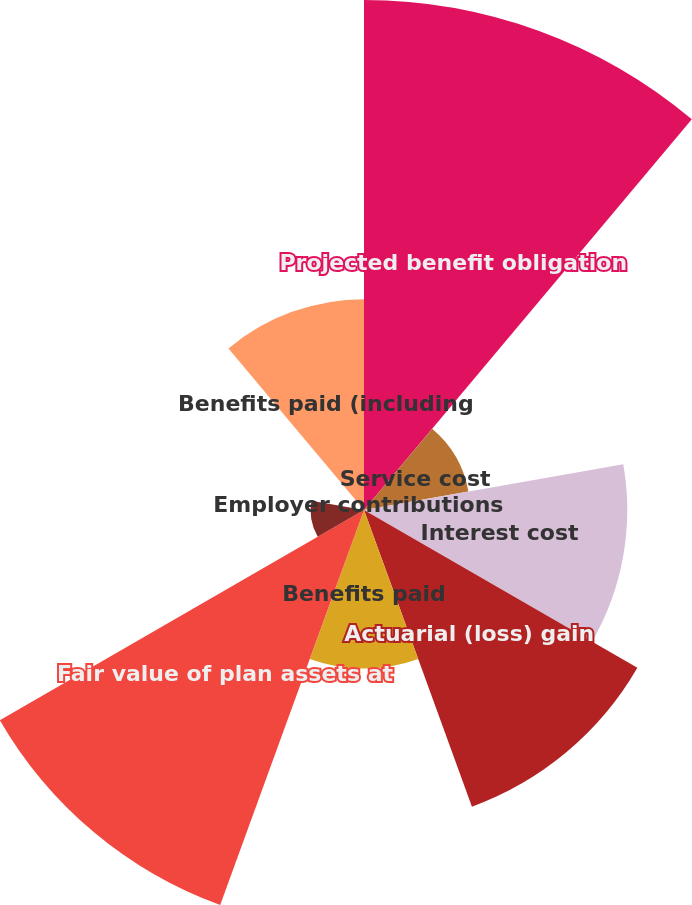Convert chart. <chart><loc_0><loc_0><loc_500><loc_500><pie_chart><fcel>Projected benefit obligation<fcel>Service cost<fcel>Interest cost<fcel>Actuarial (loss) gain<fcel>Benefits paid<fcel>Fair value of plan assets at<fcel>Actual return on plan assets<fcel>Employer contributions<fcel>Benefits paid (including<nl><fcel>25.01%<fcel>5.2%<fcel>12.91%<fcel>15.48%<fcel>7.77%<fcel>20.62%<fcel>2.62%<fcel>0.05%<fcel>10.34%<nl></chart> 